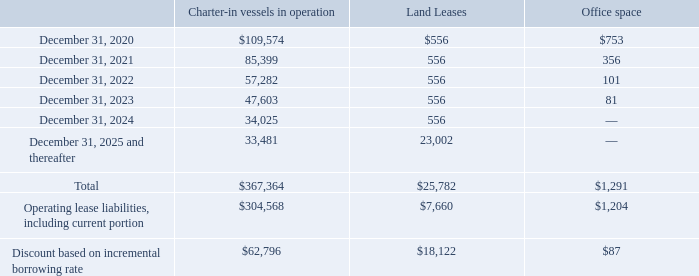NAVIOS MARITIME HOLDINGS INC. NOTES TO THE CONSOLIDATED FINANCIAL STATEMENTS (Expressed in thousands of U.S. dollars — except share data)
The Company entered into new lease liabilities amounting to $47,064 during the year ended December 31, 2019.
The table below provides the total amount of lease payments on an undiscounted basis on our chartered-in contracts, office lease agreements and land lease agreements as of December 31, 2019:
As of December 31, 2019, the weighted average remaining lease terms on our charter-in contracts, office lease agreements and land leases are 4.5 years, 1.9 years and 46.3 years, respectively.
What was the weighted average remaining lease terms on the company's land leases as of end 2019? 46.3 years. What were the payments for office space in 2022?
Answer scale should be: thousand. 101. What were the payments for Charter-in vessels in operation in 2020?
Answer scale should be: thousand. 109,574. Which lease payments had a total that exceeded $100,000 thousand? (Charter-in vessels in operation:367,364)
Answer: charter-in vessels in operation. What was the change in the payments for Charter-in vessels in operation between 2022 and 2023?
Answer scale should be: thousand. 47,603-57,282
Answer: -9679. What was the difference in the Discount based on incremental borrowing rate between Charter-in vessels in operation and Land Leases? 
Answer scale should be: thousand. 62,796-18,122
Answer: 44674. 